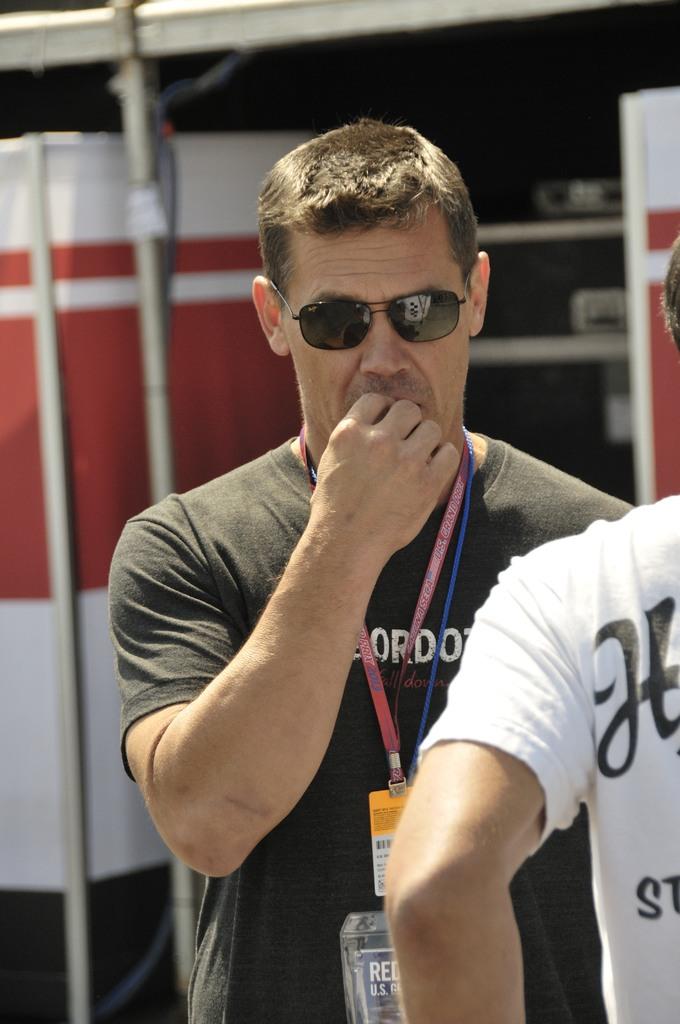What is the first letter on the white t-shirt?
Your response must be concise. H. 